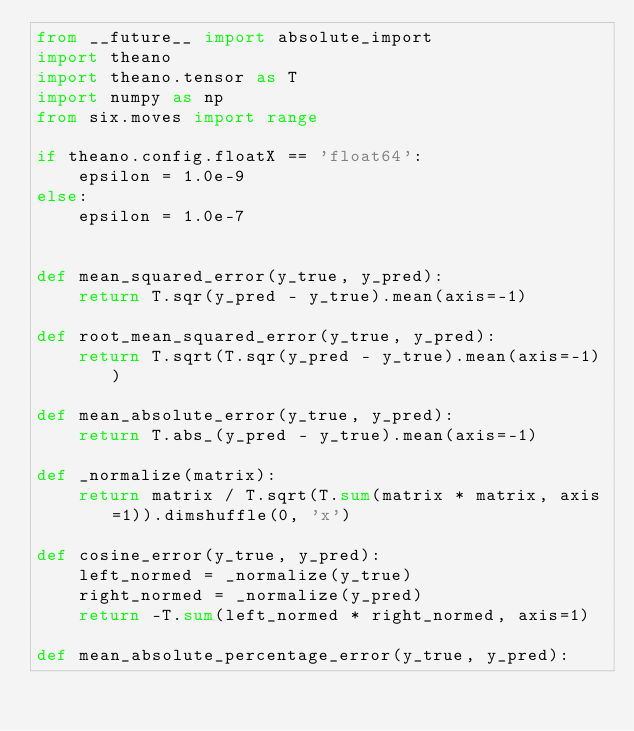Convert code to text. <code><loc_0><loc_0><loc_500><loc_500><_Python_>from __future__ import absolute_import
import theano
import theano.tensor as T
import numpy as np
from six.moves import range

if theano.config.floatX == 'float64':
    epsilon = 1.0e-9
else:
    epsilon = 1.0e-7


def mean_squared_error(y_true, y_pred):
    return T.sqr(y_pred - y_true).mean(axis=-1)

def root_mean_squared_error(y_true, y_pred):
    return T.sqrt(T.sqr(y_pred - y_true).mean(axis=-1))

def mean_absolute_error(y_true, y_pred):
    return T.abs_(y_pred - y_true).mean(axis=-1)

def _normalize(matrix):
    return matrix / T.sqrt(T.sum(matrix * matrix, axis=1)).dimshuffle(0, 'x')

def cosine_error(y_true, y_pred):
    left_normed = _normalize(y_true)
    right_normed = _normalize(y_pred)
    return -T.sum(left_normed * right_normed, axis=1)

def mean_absolute_percentage_error(y_true, y_pred):</code> 